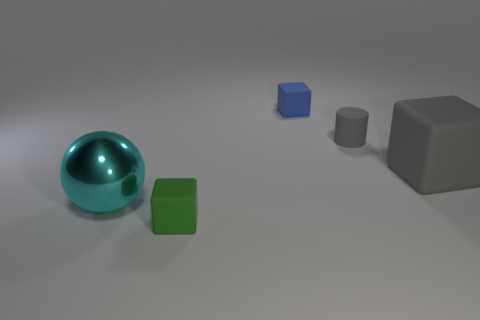Add 2 big cyan metallic things. How many objects exist? 7 Subtract all large gray cubes. How many cubes are left? 2 Subtract all yellow balls. Subtract all cyan blocks. How many balls are left? 1 Subtract all brown spheres. How many green cylinders are left? 0 Subtract all big red metal things. Subtract all small things. How many objects are left? 2 Add 3 small green matte blocks. How many small green matte blocks are left? 4 Add 3 large things. How many large things exist? 5 Subtract all blue blocks. How many blocks are left? 2 Subtract 1 blue cubes. How many objects are left? 4 Subtract all cubes. How many objects are left? 2 